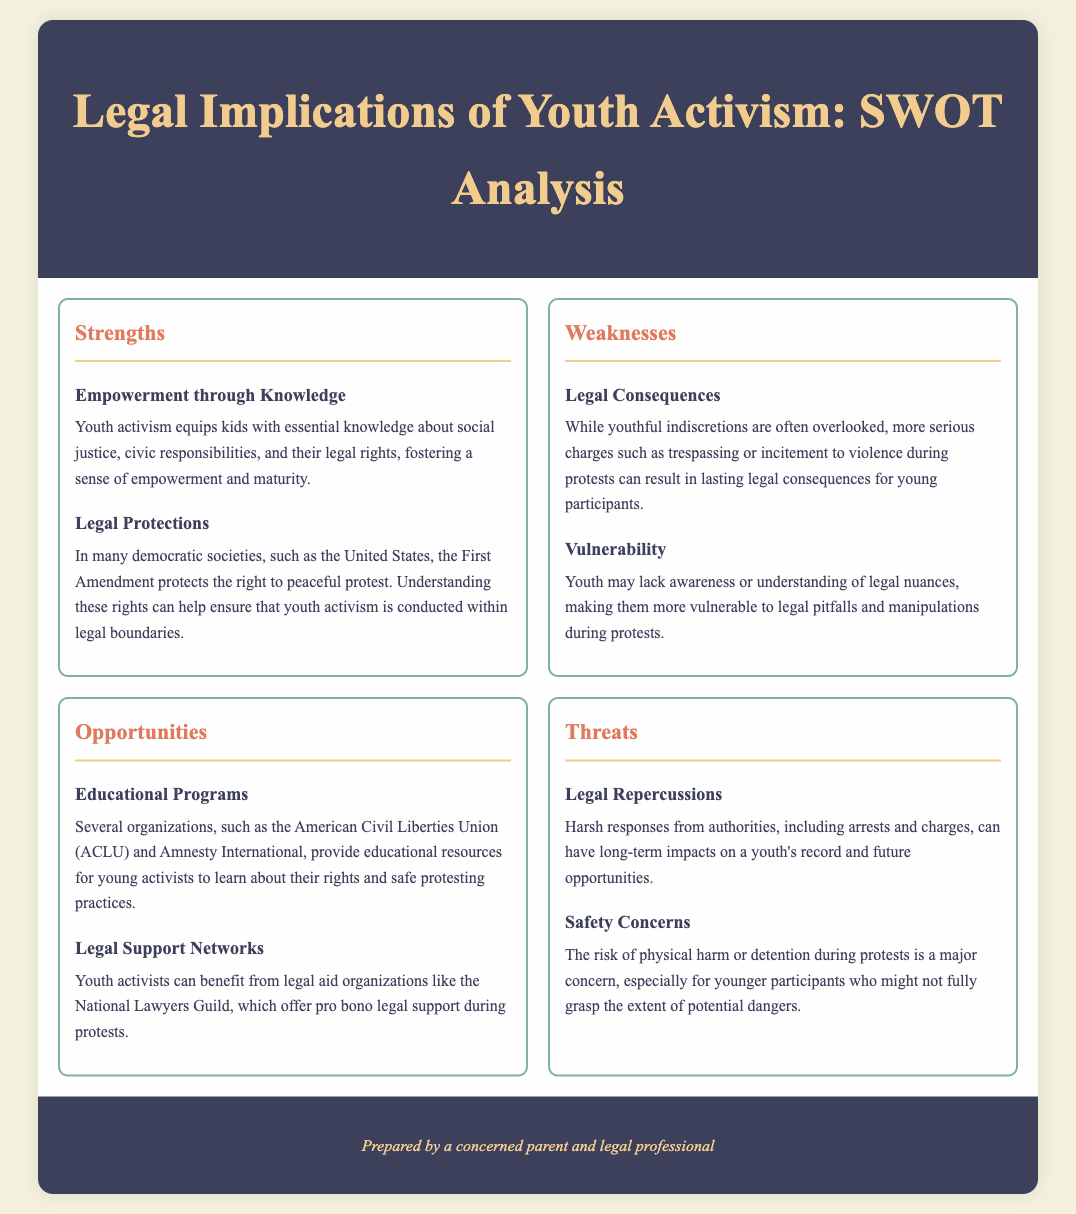What are two strengths of youth activism? The document lists empowerment through knowledge and legal protections as strengths of youth activism.
Answer: Empowerment through knowledge, Legal protections What does the First Amendment protect? The document states that the First Amendment protects the right to peaceful protest.
Answer: Right to peaceful protest What is one weakness related to legal consequences? The document mentions that serious charges can result in lasting legal consequences.
Answer: Lasting legal consequences Name an opportunity for youth activists. The document lists educational programs and legal support networks as opportunities for youth activists.
Answer: Educational programs What is a major threat to youth participation in activism? The document highlights legal repercussions as a significant threat.
Answer: Legal repercussions What organization offers educational resources for young activists? The document references the American Civil Liberties Union (ACLU) as an organization providing educational resources.
Answer: American Civil Liberties Union (ACLU) How can youth activists receive legal support? The document mentions organizations like the National Lawyers Guild that offer pro bono legal support.
Answer: National Lawyers Guild What concern is raised about youth protesters during demonstrations? The document raises safety concerns regarding physical harm or detention during protests.
Answer: Physical harm or detention What is a potential legal consequence mentioned for youth participants? The document notes that serious charges, such as trespassing or incitement to violence, can be a legal consequence.
Answer: Trespassing or incitement to violence 